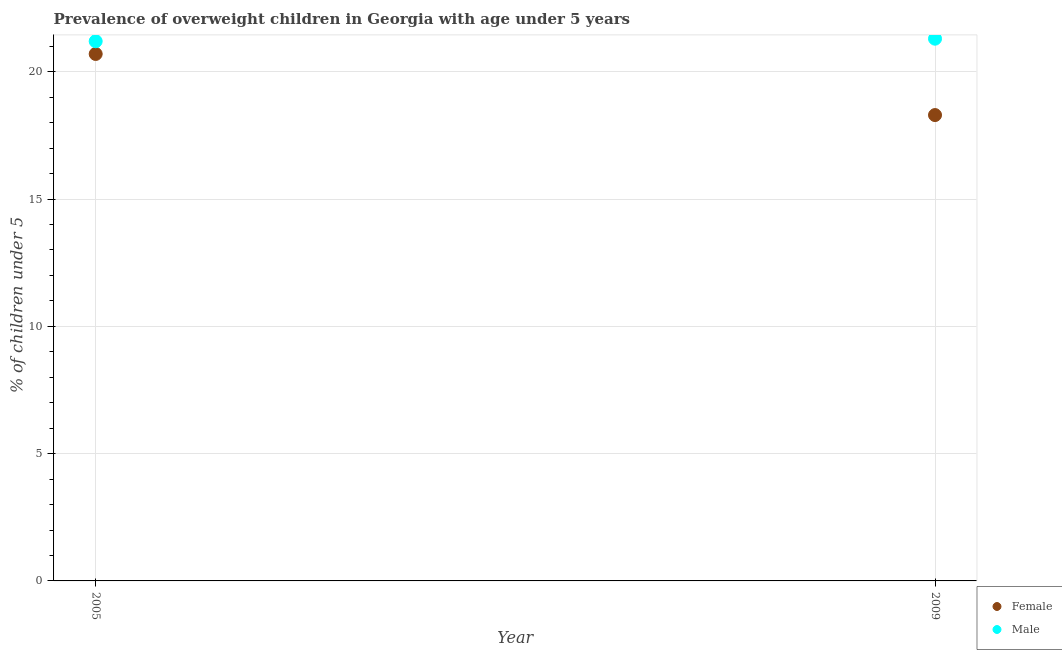What is the percentage of obese female children in 2005?
Provide a succinct answer. 20.7. Across all years, what is the maximum percentage of obese male children?
Offer a terse response. 21.3. Across all years, what is the minimum percentage of obese male children?
Offer a very short reply. 21.2. In which year was the percentage of obese male children maximum?
Offer a terse response. 2009. In which year was the percentage of obese female children minimum?
Offer a very short reply. 2009. What is the total percentage of obese male children in the graph?
Make the answer very short. 42.5. What is the difference between the percentage of obese female children in 2005 and that in 2009?
Offer a very short reply. 2.4. What is the difference between the percentage of obese male children in 2009 and the percentage of obese female children in 2005?
Offer a terse response. 0.6. In how many years, is the percentage of obese female children greater than 6 %?
Your answer should be compact. 2. What is the ratio of the percentage of obese female children in 2005 to that in 2009?
Provide a short and direct response. 1.13. Is the percentage of obese male children in 2005 less than that in 2009?
Keep it short and to the point. Yes. Does the percentage of obese male children monotonically increase over the years?
Your response must be concise. Yes. Is the percentage of obese female children strictly greater than the percentage of obese male children over the years?
Your response must be concise. No. How many years are there in the graph?
Offer a very short reply. 2. What is the difference between two consecutive major ticks on the Y-axis?
Offer a terse response. 5. Where does the legend appear in the graph?
Ensure brevity in your answer.  Bottom right. What is the title of the graph?
Make the answer very short. Prevalence of overweight children in Georgia with age under 5 years. What is the label or title of the Y-axis?
Keep it short and to the point.  % of children under 5. What is the  % of children under 5 in Female in 2005?
Ensure brevity in your answer.  20.7. What is the  % of children under 5 in Male in 2005?
Your response must be concise. 21.2. What is the  % of children under 5 in Female in 2009?
Make the answer very short. 18.3. What is the  % of children under 5 of Male in 2009?
Make the answer very short. 21.3. Across all years, what is the maximum  % of children under 5 in Female?
Your answer should be very brief. 20.7. Across all years, what is the maximum  % of children under 5 of Male?
Offer a terse response. 21.3. Across all years, what is the minimum  % of children under 5 of Female?
Offer a very short reply. 18.3. Across all years, what is the minimum  % of children under 5 in Male?
Keep it short and to the point. 21.2. What is the total  % of children under 5 of Female in the graph?
Give a very brief answer. 39. What is the total  % of children under 5 in Male in the graph?
Offer a terse response. 42.5. What is the difference between the  % of children under 5 of Female in 2005 and that in 2009?
Give a very brief answer. 2.4. What is the average  % of children under 5 of Male per year?
Keep it short and to the point. 21.25. In the year 2005, what is the difference between the  % of children under 5 in Female and  % of children under 5 in Male?
Ensure brevity in your answer.  -0.5. What is the ratio of the  % of children under 5 of Female in 2005 to that in 2009?
Offer a terse response. 1.13. What is the ratio of the  % of children under 5 of Male in 2005 to that in 2009?
Provide a succinct answer. 1. 